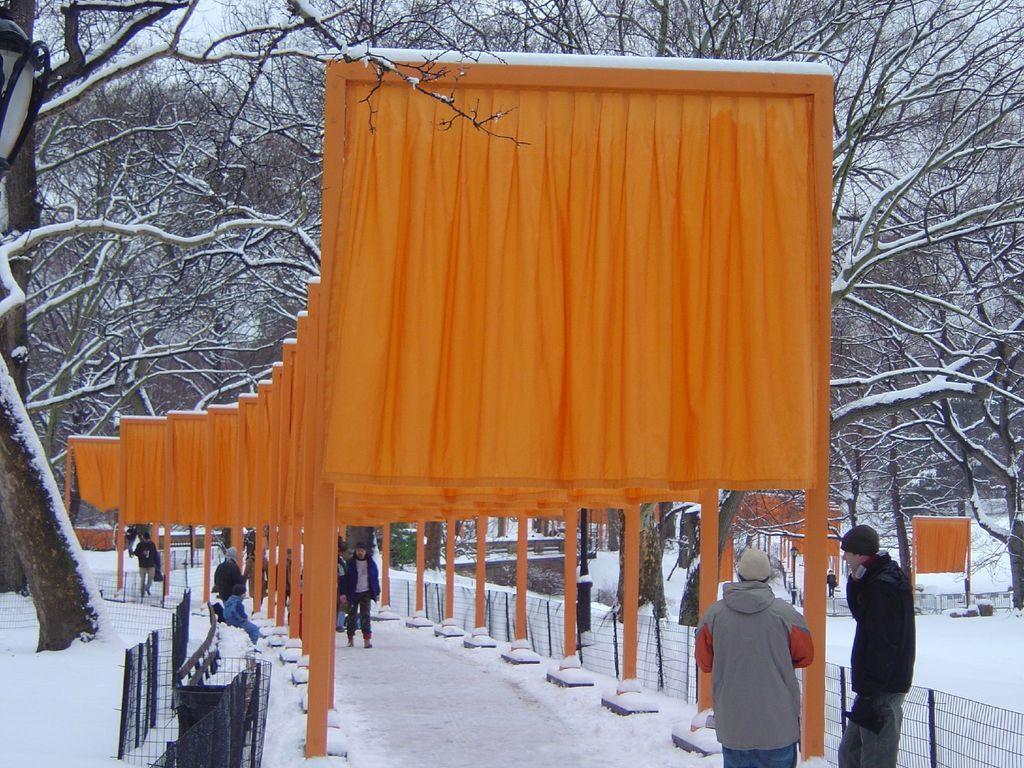Could you give a brief overview of what you see in this image? In the center of the image we can see arches. And we can see arches are decorated with orange colored clothes. And we can see fences, snow, few people are standing, few people are wearing hats, few people are wearing jackets and a few other objects. In the background we can see the sky, clouds, trees, snow, arches and a few other objects. 